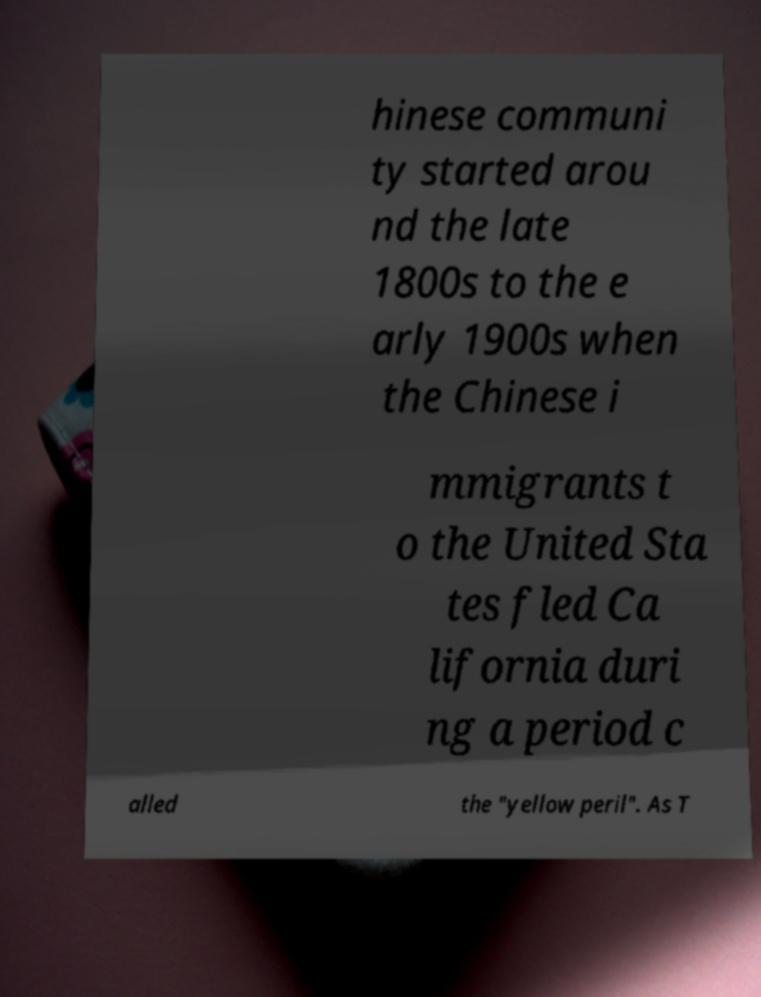What messages or text are displayed in this image? I need them in a readable, typed format. hinese communi ty started arou nd the late 1800s to the e arly 1900s when the Chinese i mmigrants t o the United Sta tes fled Ca lifornia duri ng a period c alled the "yellow peril". As T 